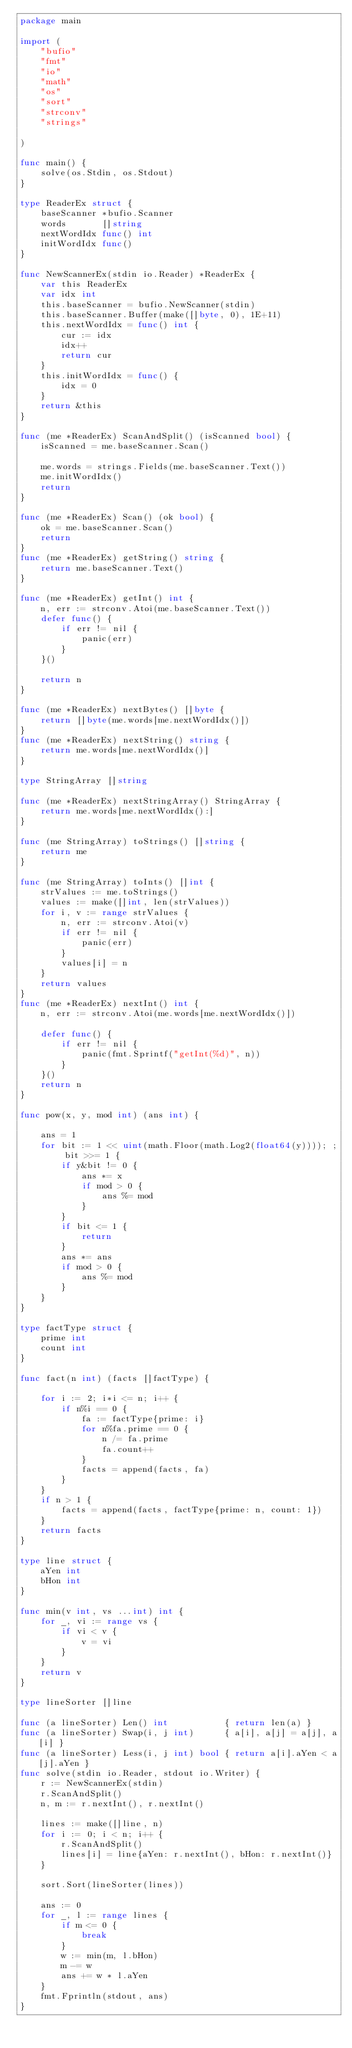<code> <loc_0><loc_0><loc_500><loc_500><_Go_>package main

import (
	"bufio"
	"fmt"
	"io"
	"math"
	"os"
	"sort"
	"strconv"
	"strings"

)

func main() {
	solve(os.Stdin, os.Stdout)
}

type ReaderEx struct {
	baseScanner *bufio.Scanner
	words       []string
	nextWordIdx func() int
	initWordIdx func()
}

func NewScannerEx(stdin io.Reader) *ReaderEx {
	var this ReaderEx
	var idx int
	this.baseScanner = bufio.NewScanner(stdin)
	this.baseScanner.Buffer(make([]byte, 0), 1E+11)
	this.nextWordIdx = func() int {
		cur := idx
		idx++
		return cur
	}
	this.initWordIdx = func() {
		idx = 0
	}
	return &this
}

func (me *ReaderEx) ScanAndSplit() (isScanned bool) {
	isScanned = me.baseScanner.Scan()

	me.words = strings.Fields(me.baseScanner.Text())
	me.initWordIdx()
	return
}

func (me *ReaderEx) Scan() (ok bool) {
	ok = me.baseScanner.Scan()
	return
}
func (me *ReaderEx) getString() string {
	return me.baseScanner.Text()
}

func (me *ReaderEx) getInt() int {
	n, err := strconv.Atoi(me.baseScanner.Text())
	defer func() {
		if err != nil {
			panic(err)
		}
	}()

	return n
}

func (me *ReaderEx) nextBytes() []byte {
	return []byte(me.words[me.nextWordIdx()])
}
func (me *ReaderEx) nextString() string {
	return me.words[me.nextWordIdx()]
}

type StringArray []string

func (me *ReaderEx) nextStringArray() StringArray {
	return me.words[me.nextWordIdx():]
}

func (me StringArray) toStrings() []string {
	return me
}

func (me StringArray) toInts() []int {
	strValues := me.toStrings()
	values := make([]int, len(strValues))
	for i, v := range strValues {
		n, err := strconv.Atoi(v)
		if err != nil {
			panic(err)
		}
		values[i] = n
	}
	return values
}
func (me *ReaderEx) nextInt() int {
	n, err := strconv.Atoi(me.words[me.nextWordIdx()])

	defer func() {
		if err != nil {
			panic(fmt.Sprintf("getInt(%d)", n))
		}
	}()
	return n
}

func pow(x, y, mod int) (ans int) {

	ans = 1
	for bit := 1 << uint(math.Floor(math.Log2(float64(y)))); ; bit >>= 1 {
		if y&bit != 0 {
			ans *= x
			if mod > 0 {
				ans %= mod
			}
		}
		if bit <= 1 {
			return
		}
		ans *= ans
		if mod > 0 {
			ans %= mod
		}
	}
}

type factType struct {
	prime int
	count int
}

func fact(n int) (facts []factType) {

	for i := 2; i*i <= n; i++ {
		if n%i == 0 {
			fa := factType{prime: i}
			for n%fa.prime == 0 {
				n /= fa.prime
				fa.count++
			}
			facts = append(facts, fa)
		}
	}
	if n > 1 {
		facts = append(facts, factType{prime: n, count: 1})
	}
	return facts
}

type line struct {
	aYen int
	bHon int
}

func min(v int, vs ...int) int {
	for _, vi := range vs {
		if vi < v {
			v = vi
		}
	}
	return v
}

type lineSorter []line

func (a lineSorter) Len() int           { return len(a) }
func (a lineSorter) Swap(i, j int)      { a[i], a[j] = a[j], a[i] }
func (a lineSorter) Less(i, j int) bool { return a[i].aYen < a[j].aYen }
func solve(stdin io.Reader, stdout io.Writer) {
	r := NewScannerEx(stdin)
	r.ScanAndSplit()
	n, m := r.nextInt(), r.nextInt()

	lines := make([]line, n)
	for i := 0; i < n; i++ {
		r.ScanAndSplit()
		lines[i] = line{aYen: r.nextInt(), bHon: r.nextInt()}
	}

	sort.Sort(lineSorter(lines))

	ans := 0
	for _, l := range lines {
		if m <= 0 {
			break
		}
		w := min(m, l.bHon)
		m -= w
		ans += w * l.aYen
	}
	fmt.Fprintln(stdout, ans)
}

</code> 